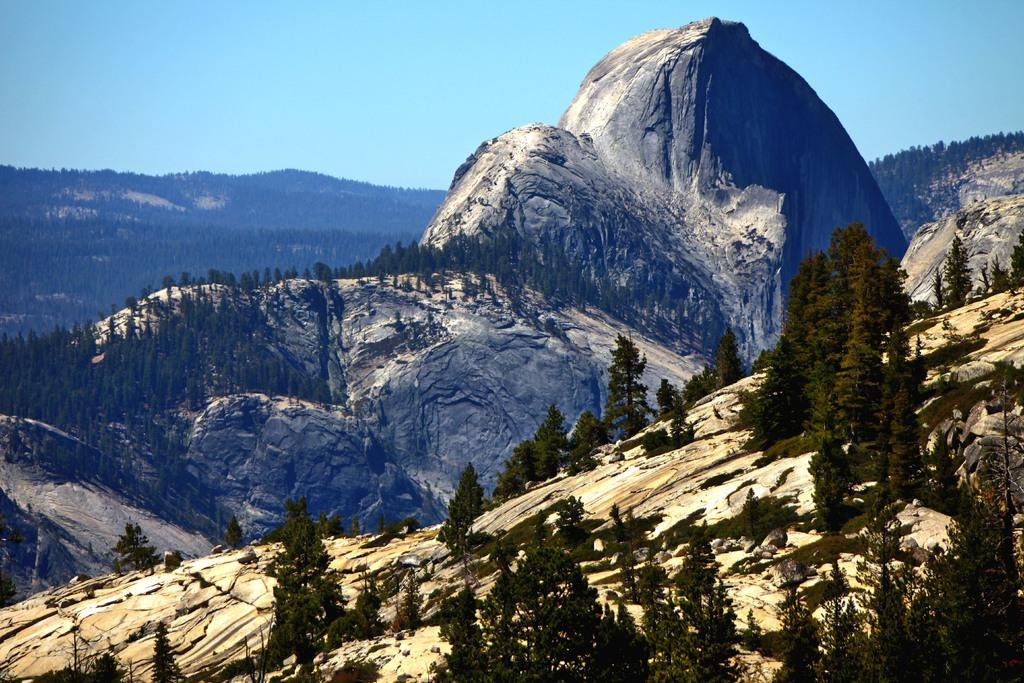What is located at the bottom of the image? There are mountains and trees at the bottom of the image. What can be seen in the background of the image? There are mountains in the background of the image. What is visible at the top of the image? The sky is visible at the top of the image. Can you see a flame in the image? There is no flame present in the image. Are the trees at the bottom of the image walking in the image? Trees do not walk; they are stationary in the image. 